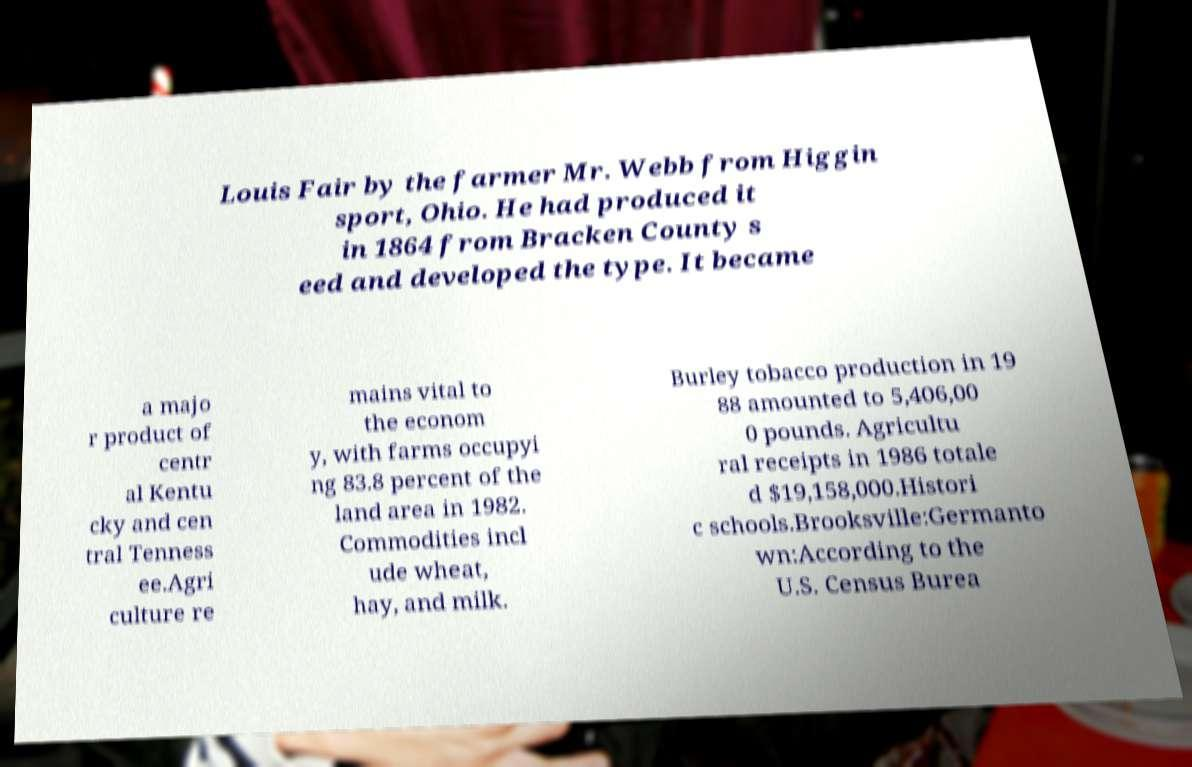Can you read and provide the text displayed in the image?This photo seems to have some interesting text. Can you extract and type it out for me? Louis Fair by the farmer Mr. Webb from Higgin sport, Ohio. He had produced it in 1864 from Bracken County s eed and developed the type. It became a majo r product of centr al Kentu cky and cen tral Tenness ee.Agri culture re mains vital to the econom y, with farms occupyi ng 83.8 percent of the land area in 1982. Commodities incl ude wheat, hay, and milk. Burley tobacco production in 19 88 amounted to 5,406,00 0 pounds. Agricultu ral receipts in 1986 totale d $19,158,000.Histori c schools.Brooksville:Germanto wn:According to the U.S. Census Burea 